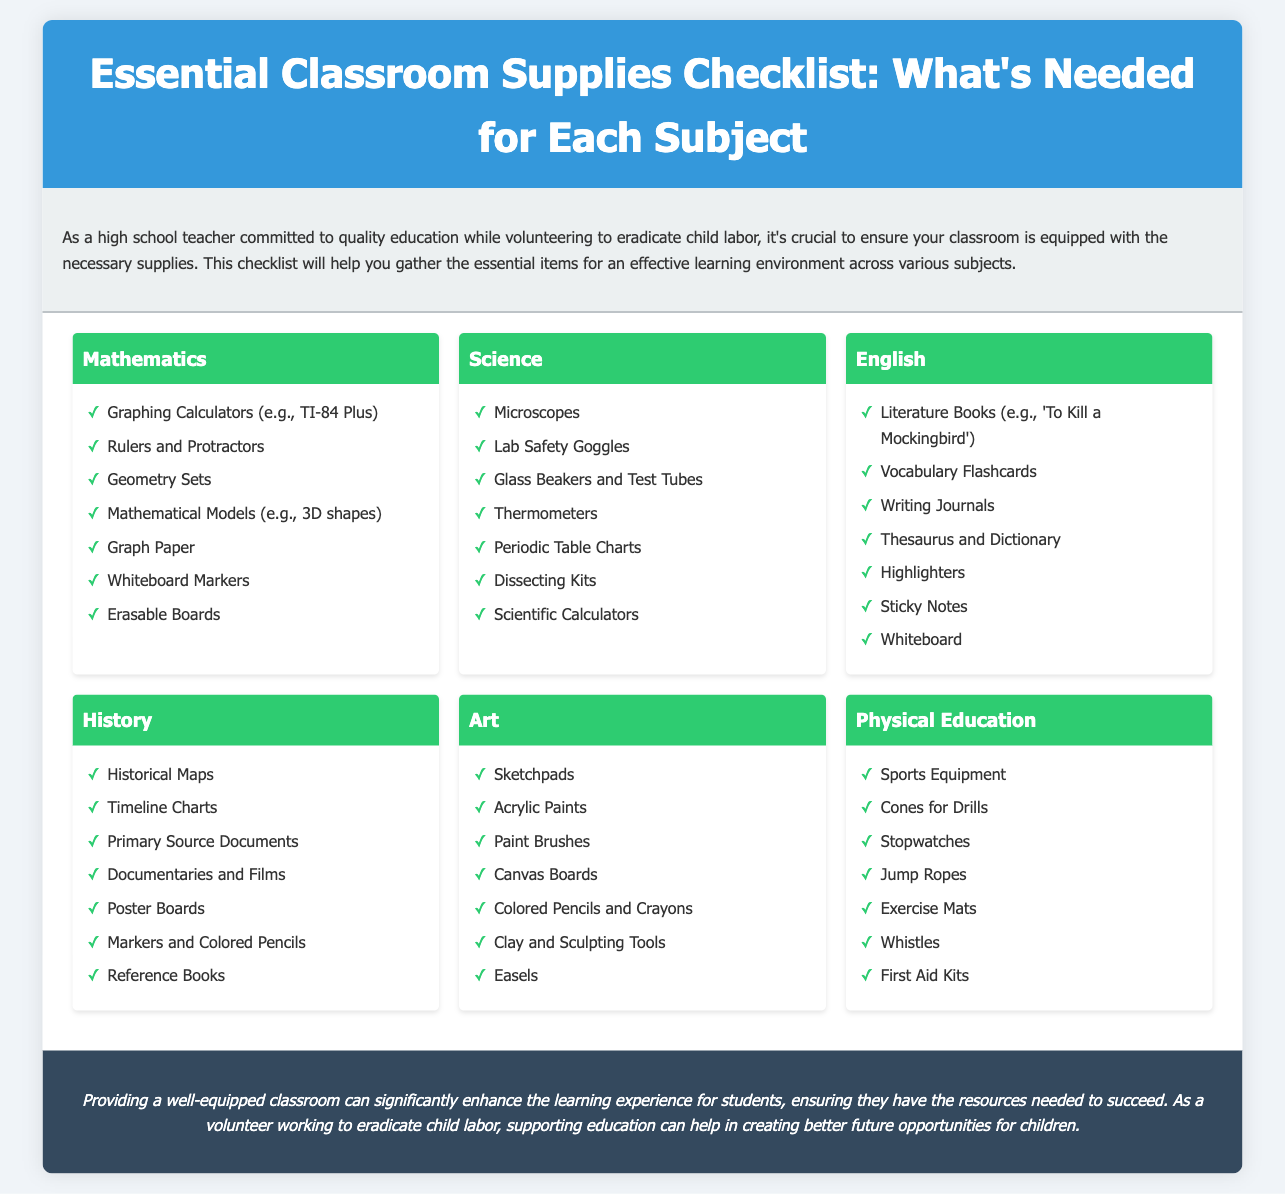What supplies are needed for Mathematics? The document lists the required supplies for Mathematics such as Graphing Calculators, Rulers, Geometry Sets, and others.
Answer: Graphing Calculators, Rulers, Geometry Sets, Mathematical Models, Graph Paper, Whiteboard Markers, Erasable Boards What equipment is necessary for Physical Education? The document mentions various supplies necessary for Physical Education, which include sports-related items.
Answer: Sports Equipment, Cones, Stopwatches, Jump Ropes, Exercise Mats, Whistles, First Aid Kits How many subjects are covered in the checklist? The document presents supplies for six different subjects in total.
Answer: Six Which subject requires laboratory safety goggles? The required supplies listed include specific items for different subjects, identifying which subject needs laboratory safety goggles.
Answer: Science What type of books is needed for English? The document specifies that certain types of literature are essential for the English subject.
Answer: Literature Books What colored items are mentioned for Art supplies? The Art section of the document specifically lists various colored supplies.
Answer: Acrylic Paints, Colored Pencils and Crayons Which subject includes the use of historical maps? The document indicates that historical maps are necessary for a specific subject.
Answer: History What item is listed for note-taking in English class? The document specifies that journals are useful for English, which is noted in the checklist.
Answer: Writing Journals 